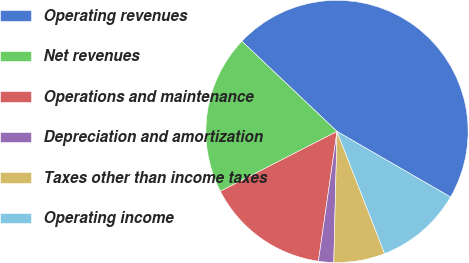Convert chart. <chart><loc_0><loc_0><loc_500><loc_500><pie_chart><fcel>Operating revenues<fcel>Net revenues<fcel>Operations and maintenance<fcel>Depreciation and amortization<fcel>Taxes other than income taxes<fcel>Operating income<nl><fcel>46.27%<fcel>19.63%<fcel>15.19%<fcel>1.87%<fcel>6.31%<fcel>10.75%<nl></chart> 